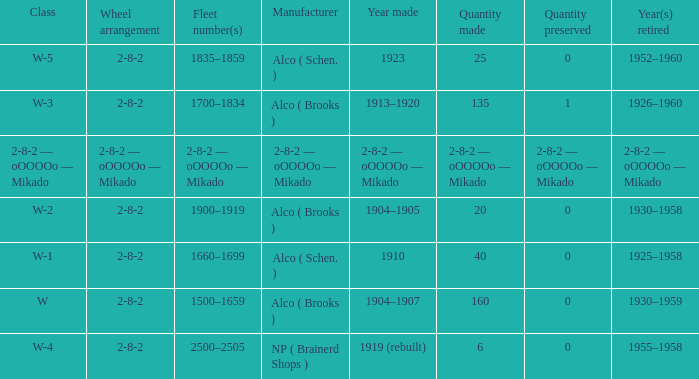What type of locomotive has a 2-8-2 wheel pattern and a production count of 25? W-5. 